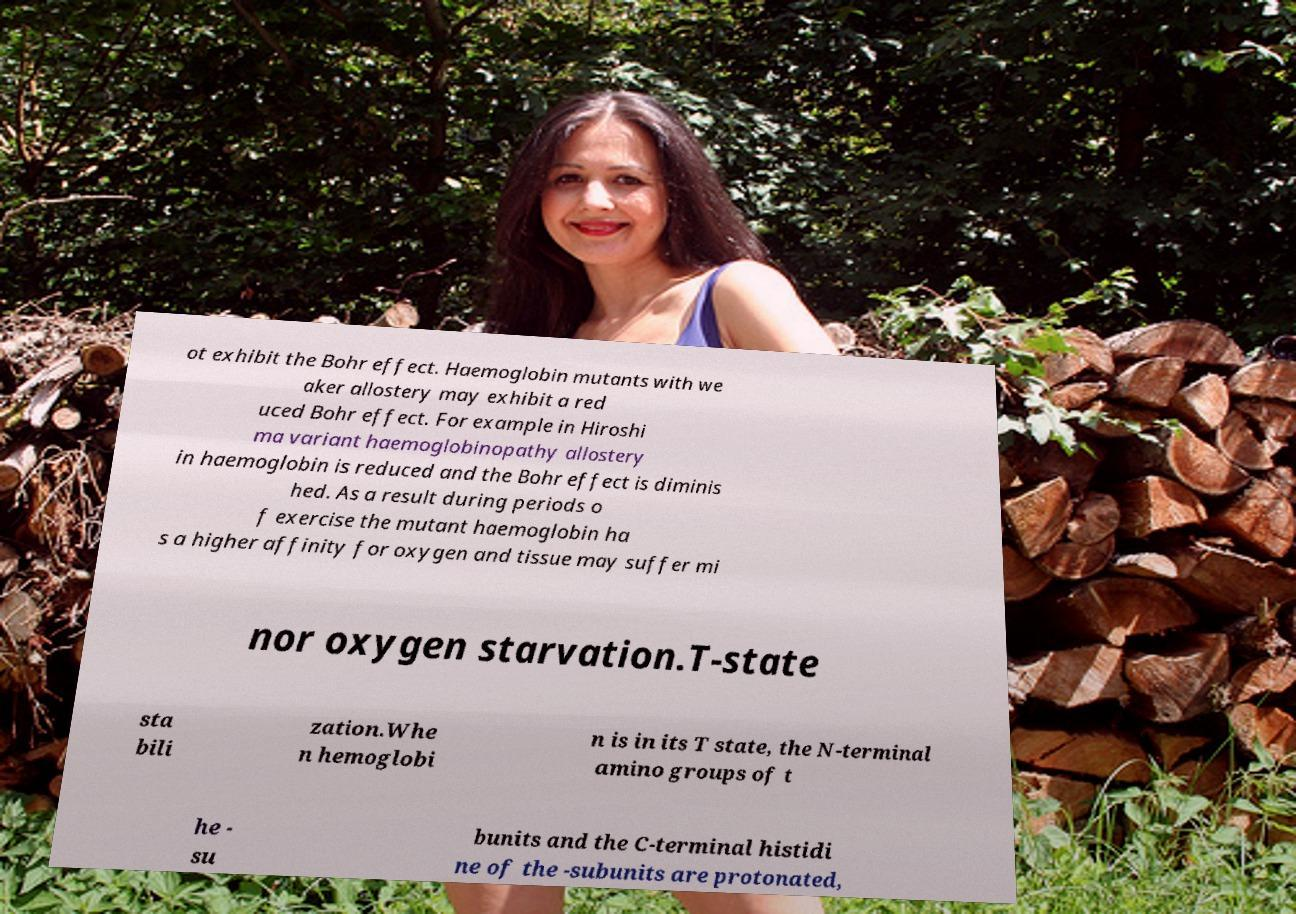Please identify and transcribe the text found in this image. ot exhibit the Bohr effect. Haemoglobin mutants with we aker allostery may exhibit a red uced Bohr effect. For example in Hiroshi ma variant haemoglobinopathy allostery in haemoglobin is reduced and the Bohr effect is diminis hed. As a result during periods o f exercise the mutant haemoglobin ha s a higher affinity for oxygen and tissue may suffer mi nor oxygen starvation.T-state sta bili zation.Whe n hemoglobi n is in its T state, the N-terminal amino groups of t he - su bunits and the C-terminal histidi ne of the -subunits are protonated, 